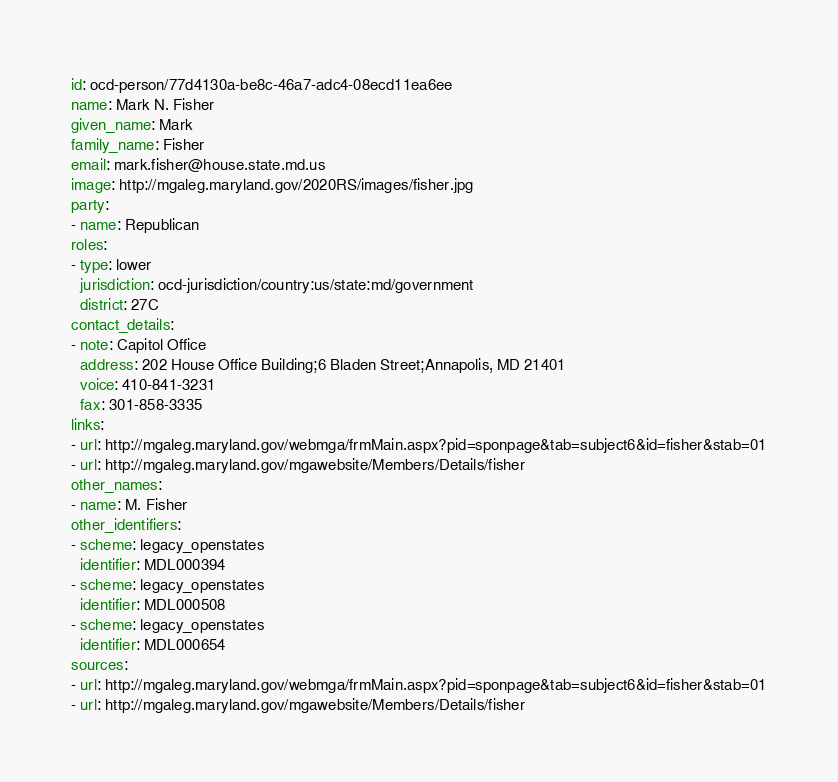Convert code to text. <code><loc_0><loc_0><loc_500><loc_500><_YAML_>id: ocd-person/77d4130a-be8c-46a7-adc4-08ecd11ea6ee
name: Mark N. Fisher
given_name: Mark
family_name: Fisher
email: mark.fisher@house.state.md.us
image: http://mgaleg.maryland.gov/2020RS/images/fisher.jpg
party:
- name: Republican
roles:
- type: lower
  jurisdiction: ocd-jurisdiction/country:us/state:md/government
  district: 27C
contact_details:
- note: Capitol Office
  address: 202 House Office Building;6 Bladen Street;Annapolis, MD 21401
  voice: 410-841-3231
  fax: 301-858-3335
links:
- url: http://mgaleg.maryland.gov/webmga/frmMain.aspx?pid=sponpage&tab=subject6&id=fisher&stab=01
- url: http://mgaleg.maryland.gov/mgawebsite/Members/Details/fisher
other_names:
- name: M. Fisher
other_identifiers:
- scheme: legacy_openstates
  identifier: MDL000394
- scheme: legacy_openstates
  identifier: MDL000508
- scheme: legacy_openstates
  identifier: MDL000654
sources:
- url: http://mgaleg.maryland.gov/webmga/frmMain.aspx?pid=sponpage&tab=subject6&id=fisher&stab=01
- url: http://mgaleg.maryland.gov/mgawebsite/Members/Details/fisher
</code> 